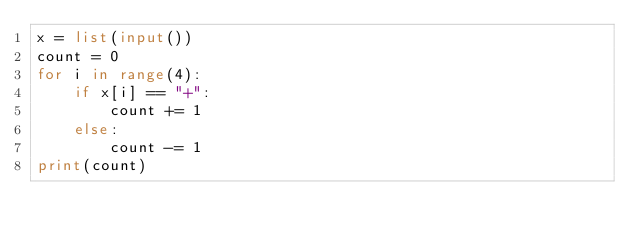Convert code to text. <code><loc_0><loc_0><loc_500><loc_500><_Python_>x = list(input())
count = 0
for i in range(4):
    if x[i] == "+":
        count += 1
    else:
        count -= 1
print(count)
</code> 